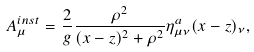Convert formula to latex. <formula><loc_0><loc_0><loc_500><loc_500>A _ { \mu } ^ { i n s t } = \frac { 2 } { g } \frac { \rho ^ { 2 } } { ( x - z ) ^ { 2 } + \rho ^ { 2 } } \eta _ { \mu \nu } ^ { a } ( x - z ) _ { \nu } ,</formula> 